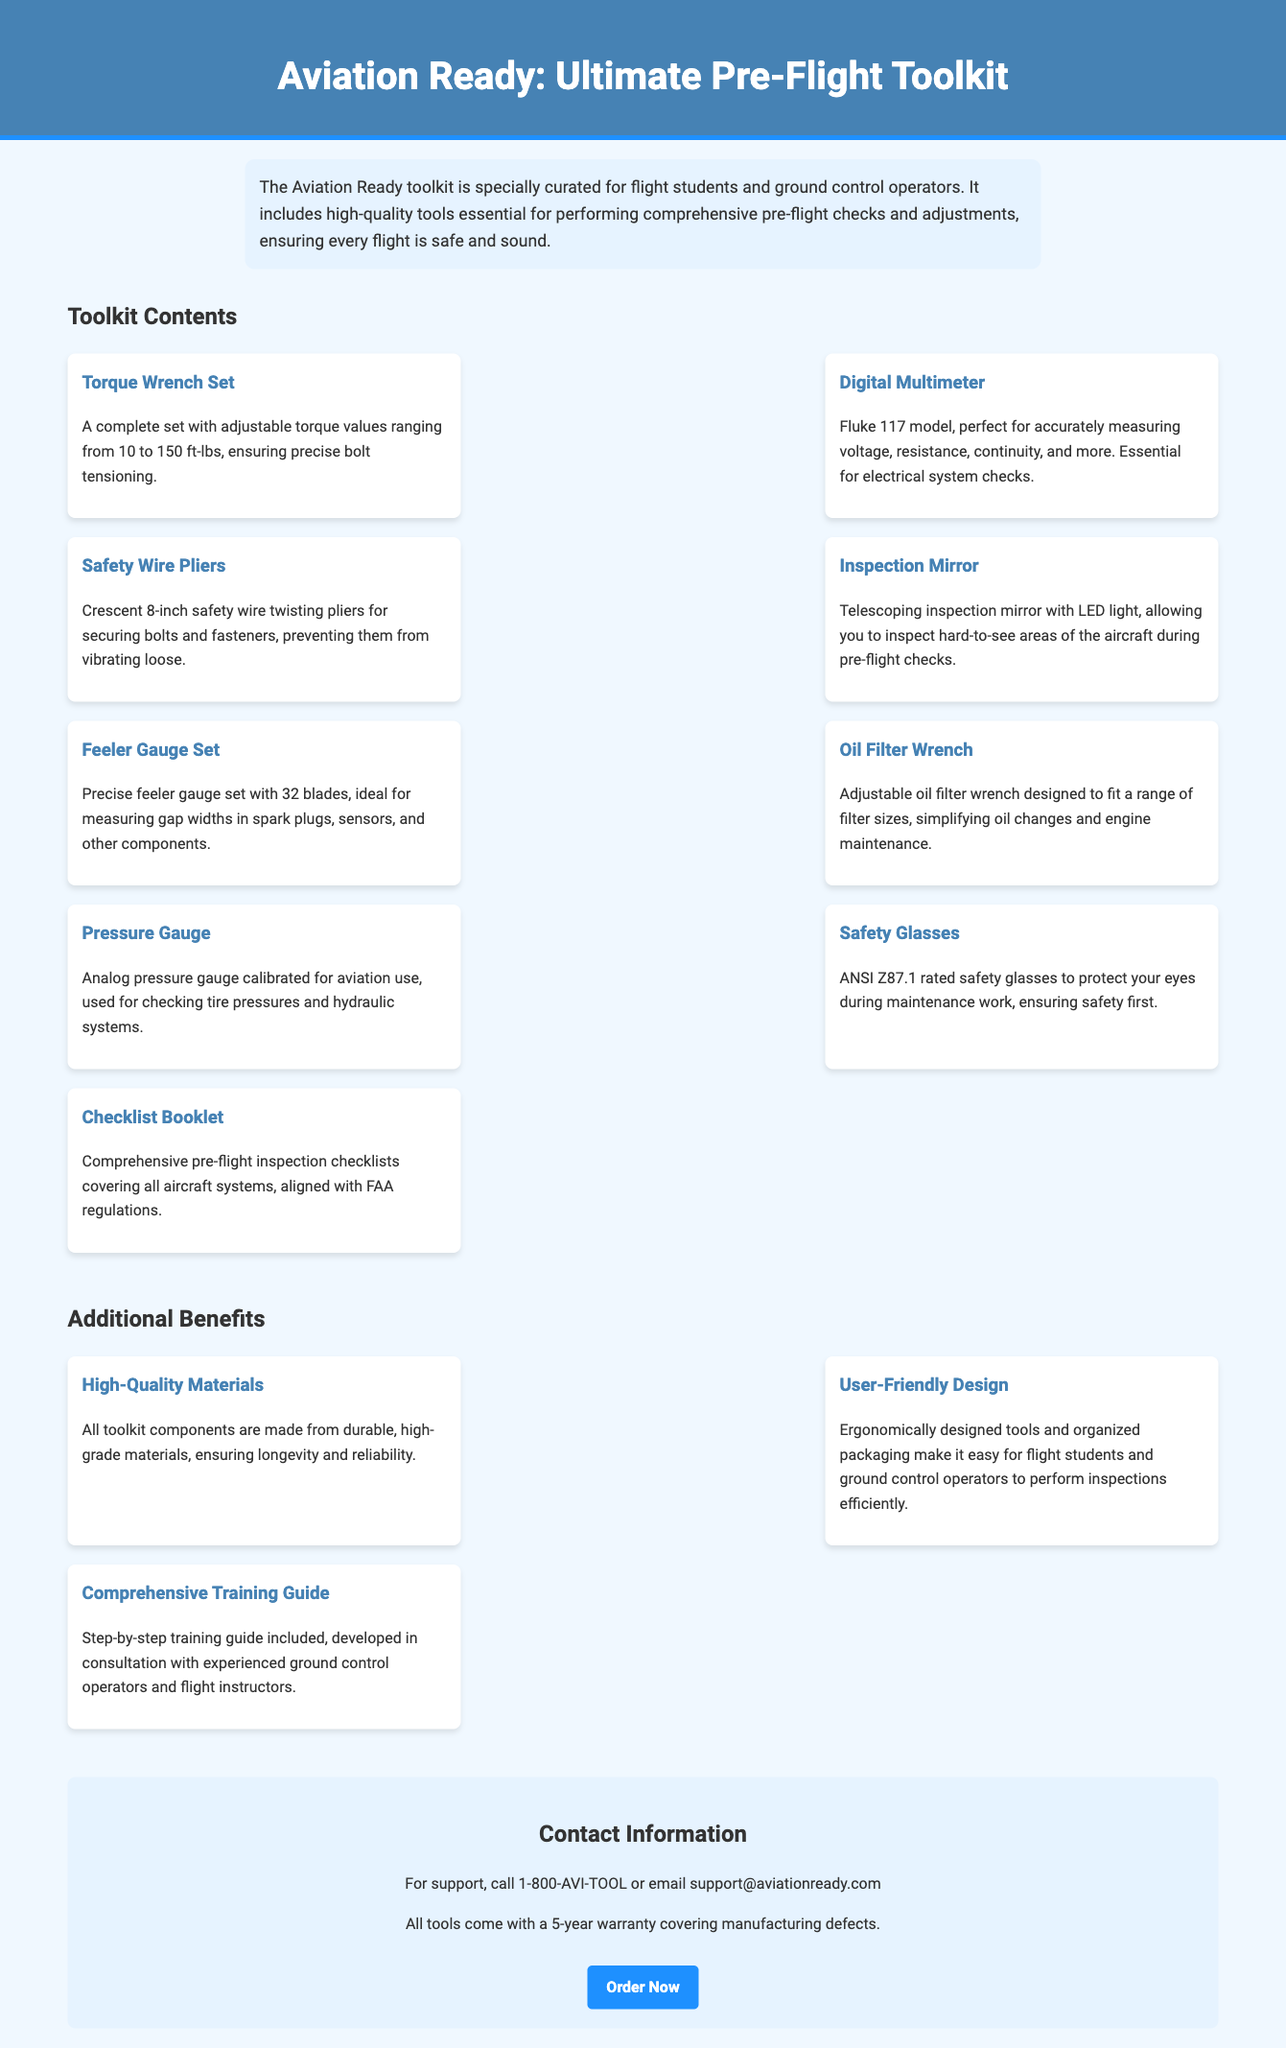What is the title of the document? The title is prominently displayed at the top of the document, which is "Aviation Ready: Ultimate Pre-Flight Toolkit."
Answer: Aviation Ready: Ultimate Pre-Flight Toolkit How many tools are listed in the toolkit contents? The toolkit contents section includes a total of ten tools listed.
Answer: 10 What model is the digital multimeter? The document specifically mentions that the digital multimeter included is the Fluke 117 model.
Answer: Fluke 117 What is the purpose of the safety wire pliers? The safety wire pliers are described in the document as being essential for securing bolts and fasteners.
Answer: Securing bolts and fasteners What type of warranty do the tools come with? The contact information section mentions that all tools include a warranty that covers manufacturing defects.
Answer: 5-year warranty What benefit is highlighted regarding the materials of the toolkit? The document states that all toolkit components are made from durable, high-grade materials, emphasizing quality.
Answer: High-Quality Materials What does the comprehensive training guide offer? The training guide included with the toolkit provides step-by-step instructions developed in consultation with experienced professionals.
Answer: Step-by-step training guide What is the primary audience for the toolkit? The description clearly states that the toolkit is specially curated for flight students and ground control operators.
Answer: Flight students and ground control operators 